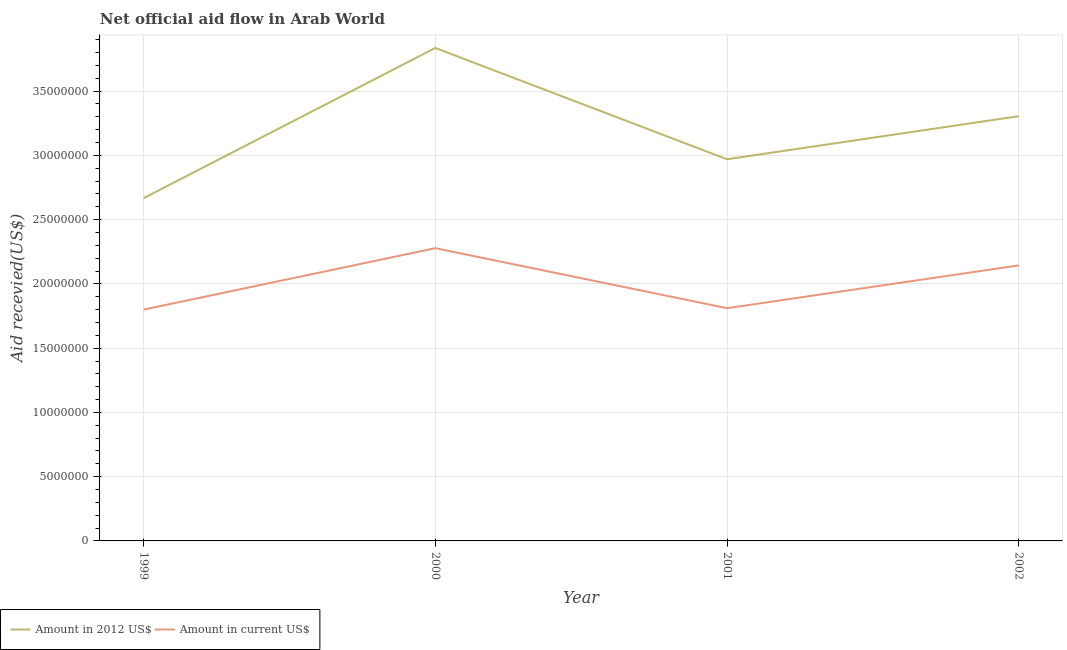How many different coloured lines are there?
Your response must be concise. 2. What is the amount of aid received(expressed in us$) in 2002?
Make the answer very short. 2.14e+07. Across all years, what is the maximum amount of aid received(expressed in 2012 us$)?
Your answer should be compact. 3.84e+07. Across all years, what is the minimum amount of aid received(expressed in 2012 us$)?
Ensure brevity in your answer.  2.67e+07. What is the total amount of aid received(expressed in 2012 us$) in the graph?
Offer a very short reply. 1.28e+08. What is the difference between the amount of aid received(expressed in us$) in 2000 and that in 2001?
Your answer should be compact. 4.67e+06. What is the difference between the amount of aid received(expressed in 2012 us$) in 2000 and the amount of aid received(expressed in us$) in 2001?
Provide a short and direct response. 2.02e+07. What is the average amount of aid received(expressed in us$) per year?
Keep it short and to the point. 2.01e+07. In the year 1999, what is the difference between the amount of aid received(expressed in us$) and amount of aid received(expressed in 2012 us$)?
Your answer should be very brief. -8.67e+06. In how many years, is the amount of aid received(expressed in us$) greater than 21000000 US$?
Your response must be concise. 2. What is the ratio of the amount of aid received(expressed in 2012 us$) in 2001 to that in 2002?
Make the answer very short. 0.9. Is the difference between the amount of aid received(expressed in us$) in 2000 and 2001 greater than the difference between the amount of aid received(expressed in 2012 us$) in 2000 and 2001?
Give a very brief answer. No. What is the difference between the highest and the second highest amount of aid received(expressed in us$)?
Give a very brief answer. 1.34e+06. What is the difference between the highest and the lowest amount of aid received(expressed in 2012 us$)?
Provide a short and direct response. 1.17e+07. How many lines are there?
Your answer should be compact. 2. How many years are there in the graph?
Ensure brevity in your answer.  4. What is the difference between two consecutive major ticks on the Y-axis?
Your answer should be very brief. 5.00e+06. Does the graph contain any zero values?
Keep it short and to the point. No. How are the legend labels stacked?
Your response must be concise. Horizontal. What is the title of the graph?
Provide a succinct answer. Net official aid flow in Arab World. What is the label or title of the Y-axis?
Offer a terse response. Aid recevied(US$). What is the Aid recevied(US$) of Amount in 2012 US$ in 1999?
Offer a very short reply. 2.67e+07. What is the Aid recevied(US$) of Amount in current US$ in 1999?
Your response must be concise. 1.80e+07. What is the Aid recevied(US$) of Amount in 2012 US$ in 2000?
Make the answer very short. 3.84e+07. What is the Aid recevied(US$) in Amount in current US$ in 2000?
Make the answer very short. 2.28e+07. What is the Aid recevied(US$) of Amount in 2012 US$ in 2001?
Provide a succinct answer. 2.97e+07. What is the Aid recevied(US$) of Amount in current US$ in 2001?
Offer a very short reply. 1.81e+07. What is the Aid recevied(US$) in Amount in 2012 US$ in 2002?
Your answer should be very brief. 3.30e+07. What is the Aid recevied(US$) of Amount in current US$ in 2002?
Your response must be concise. 2.14e+07. Across all years, what is the maximum Aid recevied(US$) of Amount in 2012 US$?
Give a very brief answer. 3.84e+07. Across all years, what is the maximum Aid recevied(US$) of Amount in current US$?
Make the answer very short. 2.28e+07. Across all years, what is the minimum Aid recevied(US$) of Amount in 2012 US$?
Provide a succinct answer. 2.67e+07. Across all years, what is the minimum Aid recevied(US$) in Amount in current US$?
Your answer should be very brief. 1.80e+07. What is the total Aid recevied(US$) in Amount in 2012 US$ in the graph?
Provide a short and direct response. 1.28e+08. What is the total Aid recevied(US$) of Amount in current US$ in the graph?
Offer a very short reply. 8.03e+07. What is the difference between the Aid recevied(US$) of Amount in 2012 US$ in 1999 and that in 2000?
Offer a very short reply. -1.17e+07. What is the difference between the Aid recevied(US$) of Amount in current US$ in 1999 and that in 2000?
Your answer should be compact. -4.78e+06. What is the difference between the Aid recevied(US$) in Amount in 2012 US$ in 1999 and that in 2001?
Offer a terse response. -3.03e+06. What is the difference between the Aid recevied(US$) of Amount in 2012 US$ in 1999 and that in 2002?
Give a very brief answer. -6.38e+06. What is the difference between the Aid recevied(US$) of Amount in current US$ in 1999 and that in 2002?
Provide a succinct answer. -3.44e+06. What is the difference between the Aid recevied(US$) in Amount in 2012 US$ in 2000 and that in 2001?
Ensure brevity in your answer.  8.66e+06. What is the difference between the Aid recevied(US$) of Amount in current US$ in 2000 and that in 2001?
Ensure brevity in your answer.  4.67e+06. What is the difference between the Aid recevied(US$) in Amount in 2012 US$ in 2000 and that in 2002?
Make the answer very short. 5.31e+06. What is the difference between the Aid recevied(US$) of Amount in current US$ in 2000 and that in 2002?
Ensure brevity in your answer.  1.34e+06. What is the difference between the Aid recevied(US$) of Amount in 2012 US$ in 2001 and that in 2002?
Give a very brief answer. -3.35e+06. What is the difference between the Aid recevied(US$) of Amount in current US$ in 2001 and that in 2002?
Your response must be concise. -3.33e+06. What is the difference between the Aid recevied(US$) in Amount in 2012 US$ in 1999 and the Aid recevied(US$) in Amount in current US$ in 2000?
Ensure brevity in your answer.  3.89e+06. What is the difference between the Aid recevied(US$) in Amount in 2012 US$ in 1999 and the Aid recevied(US$) in Amount in current US$ in 2001?
Your answer should be very brief. 8.56e+06. What is the difference between the Aid recevied(US$) of Amount in 2012 US$ in 1999 and the Aid recevied(US$) of Amount in current US$ in 2002?
Your answer should be very brief. 5.23e+06. What is the difference between the Aid recevied(US$) of Amount in 2012 US$ in 2000 and the Aid recevied(US$) of Amount in current US$ in 2001?
Offer a very short reply. 2.02e+07. What is the difference between the Aid recevied(US$) of Amount in 2012 US$ in 2000 and the Aid recevied(US$) of Amount in current US$ in 2002?
Make the answer very short. 1.69e+07. What is the difference between the Aid recevied(US$) in Amount in 2012 US$ in 2001 and the Aid recevied(US$) in Amount in current US$ in 2002?
Your answer should be very brief. 8.26e+06. What is the average Aid recevied(US$) of Amount in 2012 US$ per year?
Offer a very short reply. 3.19e+07. What is the average Aid recevied(US$) in Amount in current US$ per year?
Your response must be concise. 2.01e+07. In the year 1999, what is the difference between the Aid recevied(US$) in Amount in 2012 US$ and Aid recevied(US$) in Amount in current US$?
Ensure brevity in your answer.  8.67e+06. In the year 2000, what is the difference between the Aid recevied(US$) in Amount in 2012 US$ and Aid recevied(US$) in Amount in current US$?
Give a very brief answer. 1.56e+07. In the year 2001, what is the difference between the Aid recevied(US$) in Amount in 2012 US$ and Aid recevied(US$) in Amount in current US$?
Provide a succinct answer. 1.16e+07. In the year 2002, what is the difference between the Aid recevied(US$) of Amount in 2012 US$ and Aid recevied(US$) of Amount in current US$?
Your answer should be very brief. 1.16e+07. What is the ratio of the Aid recevied(US$) of Amount in 2012 US$ in 1999 to that in 2000?
Offer a terse response. 0.7. What is the ratio of the Aid recevied(US$) in Amount in current US$ in 1999 to that in 2000?
Your answer should be very brief. 0.79. What is the ratio of the Aid recevied(US$) in Amount in 2012 US$ in 1999 to that in 2001?
Provide a succinct answer. 0.9. What is the ratio of the Aid recevied(US$) in Amount in 2012 US$ in 1999 to that in 2002?
Keep it short and to the point. 0.81. What is the ratio of the Aid recevied(US$) of Amount in current US$ in 1999 to that in 2002?
Ensure brevity in your answer.  0.84. What is the ratio of the Aid recevied(US$) of Amount in 2012 US$ in 2000 to that in 2001?
Provide a short and direct response. 1.29. What is the ratio of the Aid recevied(US$) of Amount in current US$ in 2000 to that in 2001?
Make the answer very short. 1.26. What is the ratio of the Aid recevied(US$) of Amount in 2012 US$ in 2000 to that in 2002?
Provide a short and direct response. 1.16. What is the ratio of the Aid recevied(US$) of Amount in 2012 US$ in 2001 to that in 2002?
Your answer should be very brief. 0.9. What is the ratio of the Aid recevied(US$) of Amount in current US$ in 2001 to that in 2002?
Ensure brevity in your answer.  0.84. What is the difference between the highest and the second highest Aid recevied(US$) in Amount in 2012 US$?
Offer a terse response. 5.31e+06. What is the difference between the highest and the second highest Aid recevied(US$) of Amount in current US$?
Provide a succinct answer. 1.34e+06. What is the difference between the highest and the lowest Aid recevied(US$) in Amount in 2012 US$?
Your answer should be very brief. 1.17e+07. What is the difference between the highest and the lowest Aid recevied(US$) in Amount in current US$?
Offer a very short reply. 4.78e+06. 